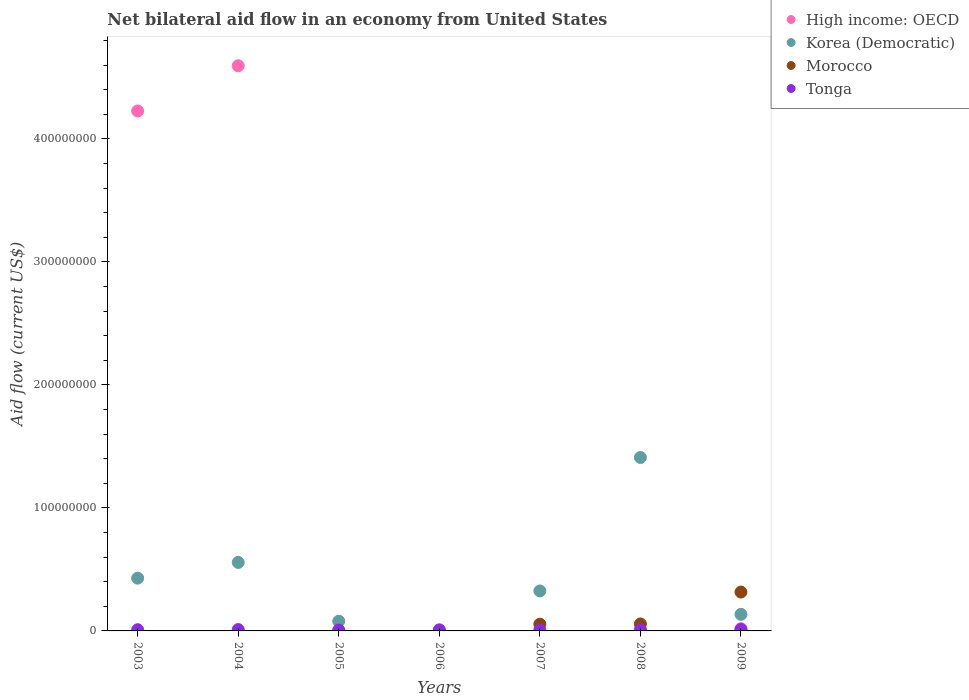Across all years, what is the maximum net bilateral aid flow in Morocco?
Ensure brevity in your answer.  3.16e+07. Across all years, what is the minimum net bilateral aid flow in Tonga?
Keep it short and to the point. 7.40e+05. In which year was the net bilateral aid flow in High income: OECD maximum?
Make the answer very short. 2004. What is the total net bilateral aid flow in Korea (Democratic) in the graph?
Offer a terse response. 2.94e+08. What is the difference between the net bilateral aid flow in Tonga in 2003 and that in 2005?
Keep it short and to the point. 2.40e+05. What is the average net bilateral aid flow in Morocco per year?
Your answer should be very brief. 6.11e+06. In the year 2007, what is the difference between the net bilateral aid flow in Korea (Democratic) and net bilateral aid flow in Morocco?
Give a very brief answer. 2.70e+07. What is the ratio of the net bilateral aid flow in Morocco in 2008 to that in 2009?
Your answer should be compact. 0.18. Is the difference between the net bilateral aid flow in Korea (Democratic) in 2007 and 2008 greater than the difference between the net bilateral aid flow in Morocco in 2007 and 2008?
Offer a terse response. No. What is the difference between the highest and the second highest net bilateral aid flow in Morocco?
Provide a succinct answer. 2.59e+07. In how many years, is the net bilateral aid flow in Korea (Democratic) greater than the average net bilateral aid flow in Korea (Democratic) taken over all years?
Offer a very short reply. 3. Is it the case that in every year, the sum of the net bilateral aid flow in Tonga and net bilateral aid flow in High income: OECD  is greater than the sum of net bilateral aid flow in Korea (Democratic) and net bilateral aid flow in Morocco?
Offer a terse response. No. Is it the case that in every year, the sum of the net bilateral aid flow in High income: OECD and net bilateral aid flow in Tonga  is greater than the net bilateral aid flow in Morocco?
Provide a short and direct response. No. Is the net bilateral aid flow in Tonga strictly less than the net bilateral aid flow in Morocco over the years?
Offer a terse response. No. How many dotlines are there?
Offer a terse response. 4. How many years are there in the graph?
Provide a succinct answer. 7. How many legend labels are there?
Provide a short and direct response. 4. How are the legend labels stacked?
Provide a short and direct response. Vertical. What is the title of the graph?
Provide a succinct answer. Net bilateral aid flow in an economy from United States. Does "Bermuda" appear as one of the legend labels in the graph?
Ensure brevity in your answer.  No. What is the Aid flow (current US$) of High income: OECD in 2003?
Your response must be concise. 4.23e+08. What is the Aid flow (current US$) of Korea (Democratic) in 2003?
Ensure brevity in your answer.  4.29e+07. What is the Aid flow (current US$) in Morocco in 2003?
Provide a short and direct response. 0. What is the Aid flow (current US$) of Tonga in 2003?
Provide a short and direct response. 9.80e+05. What is the Aid flow (current US$) in High income: OECD in 2004?
Give a very brief answer. 4.60e+08. What is the Aid flow (current US$) in Korea (Democratic) in 2004?
Your answer should be very brief. 5.57e+07. What is the Aid flow (current US$) in Morocco in 2004?
Offer a terse response. 0. What is the Aid flow (current US$) in Tonga in 2004?
Provide a succinct answer. 1.09e+06. What is the Aid flow (current US$) of High income: OECD in 2005?
Your response must be concise. 0. What is the Aid flow (current US$) of Korea (Democratic) in 2005?
Make the answer very short. 7.91e+06. What is the Aid flow (current US$) of Tonga in 2005?
Ensure brevity in your answer.  7.40e+05. What is the Aid flow (current US$) in High income: OECD in 2006?
Give a very brief answer. 0. What is the Aid flow (current US$) in Morocco in 2006?
Give a very brief answer. 0. What is the Aid flow (current US$) in Korea (Democratic) in 2007?
Offer a terse response. 3.25e+07. What is the Aid flow (current US$) of Morocco in 2007?
Provide a succinct answer. 5.49e+06. What is the Aid flow (current US$) of Tonga in 2007?
Offer a terse response. 7.70e+05. What is the Aid flow (current US$) of High income: OECD in 2008?
Your answer should be compact. 9.50e+05. What is the Aid flow (current US$) of Korea (Democratic) in 2008?
Provide a short and direct response. 1.41e+08. What is the Aid flow (current US$) in Morocco in 2008?
Give a very brief answer. 5.68e+06. What is the Aid flow (current US$) of Tonga in 2008?
Offer a terse response. 8.30e+05. What is the Aid flow (current US$) of High income: OECD in 2009?
Give a very brief answer. 1.84e+06. What is the Aid flow (current US$) of Korea (Democratic) in 2009?
Offer a very short reply. 1.35e+07. What is the Aid flow (current US$) of Morocco in 2009?
Offer a terse response. 3.16e+07. What is the Aid flow (current US$) of Tonga in 2009?
Keep it short and to the point. 1.21e+06. Across all years, what is the maximum Aid flow (current US$) in High income: OECD?
Your response must be concise. 4.60e+08. Across all years, what is the maximum Aid flow (current US$) in Korea (Democratic)?
Provide a short and direct response. 1.41e+08. Across all years, what is the maximum Aid flow (current US$) of Morocco?
Keep it short and to the point. 3.16e+07. Across all years, what is the maximum Aid flow (current US$) of Tonga?
Ensure brevity in your answer.  1.21e+06. Across all years, what is the minimum Aid flow (current US$) of High income: OECD?
Your response must be concise. 0. Across all years, what is the minimum Aid flow (current US$) of Morocco?
Provide a short and direct response. 0. Across all years, what is the minimum Aid flow (current US$) in Tonga?
Ensure brevity in your answer.  7.40e+05. What is the total Aid flow (current US$) in High income: OECD in the graph?
Offer a very short reply. 8.85e+08. What is the total Aid flow (current US$) in Korea (Democratic) in the graph?
Ensure brevity in your answer.  2.94e+08. What is the total Aid flow (current US$) of Morocco in the graph?
Offer a terse response. 4.28e+07. What is the total Aid flow (current US$) of Tonga in the graph?
Give a very brief answer. 6.52e+06. What is the difference between the Aid flow (current US$) in High income: OECD in 2003 and that in 2004?
Provide a succinct answer. -3.68e+07. What is the difference between the Aid flow (current US$) in Korea (Democratic) in 2003 and that in 2004?
Provide a short and direct response. -1.28e+07. What is the difference between the Aid flow (current US$) in Korea (Democratic) in 2003 and that in 2005?
Keep it short and to the point. 3.50e+07. What is the difference between the Aid flow (current US$) of Tonga in 2003 and that in 2005?
Offer a very short reply. 2.40e+05. What is the difference between the Aid flow (current US$) in Korea (Democratic) in 2003 and that in 2006?
Make the answer very short. 4.25e+07. What is the difference between the Aid flow (current US$) of Korea (Democratic) in 2003 and that in 2007?
Your answer should be very brief. 1.04e+07. What is the difference between the Aid flow (current US$) of High income: OECD in 2003 and that in 2008?
Give a very brief answer. 4.22e+08. What is the difference between the Aid flow (current US$) of Korea (Democratic) in 2003 and that in 2008?
Provide a short and direct response. -9.81e+07. What is the difference between the Aid flow (current US$) in High income: OECD in 2003 and that in 2009?
Make the answer very short. 4.21e+08. What is the difference between the Aid flow (current US$) of Korea (Democratic) in 2003 and that in 2009?
Your answer should be very brief. 2.94e+07. What is the difference between the Aid flow (current US$) of Korea (Democratic) in 2004 and that in 2005?
Provide a succinct answer. 4.78e+07. What is the difference between the Aid flow (current US$) in Tonga in 2004 and that in 2005?
Keep it short and to the point. 3.50e+05. What is the difference between the Aid flow (current US$) of Korea (Democratic) in 2004 and that in 2006?
Offer a very short reply. 5.53e+07. What is the difference between the Aid flow (current US$) in Korea (Democratic) in 2004 and that in 2007?
Your response must be concise. 2.32e+07. What is the difference between the Aid flow (current US$) in High income: OECD in 2004 and that in 2008?
Provide a succinct answer. 4.59e+08. What is the difference between the Aid flow (current US$) of Korea (Democratic) in 2004 and that in 2008?
Provide a short and direct response. -8.53e+07. What is the difference between the Aid flow (current US$) of Tonga in 2004 and that in 2008?
Provide a succinct answer. 2.60e+05. What is the difference between the Aid flow (current US$) of High income: OECD in 2004 and that in 2009?
Provide a short and direct response. 4.58e+08. What is the difference between the Aid flow (current US$) in Korea (Democratic) in 2004 and that in 2009?
Give a very brief answer. 4.22e+07. What is the difference between the Aid flow (current US$) in Korea (Democratic) in 2005 and that in 2006?
Provide a short and direct response. 7.51e+06. What is the difference between the Aid flow (current US$) in Korea (Democratic) in 2005 and that in 2007?
Make the answer very short. -2.46e+07. What is the difference between the Aid flow (current US$) of Tonga in 2005 and that in 2007?
Offer a terse response. -3.00e+04. What is the difference between the Aid flow (current US$) of Korea (Democratic) in 2005 and that in 2008?
Your answer should be very brief. -1.33e+08. What is the difference between the Aid flow (current US$) in Tonga in 2005 and that in 2008?
Offer a very short reply. -9.00e+04. What is the difference between the Aid flow (current US$) in Korea (Democratic) in 2005 and that in 2009?
Your answer should be very brief. -5.58e+06. What is the difference between the Aid flow (current US$) in Tonga in 2005 and that in 2009?
Offer a terse response. -4.70e+05. What is the difference between the Aid flow (current US$) in Korea (Democratic) in 2006 and that in 2007?
Give a very brief answer. -3.21e+07. What is the difference between the Aid flow (current US$) of Korea (Democratic) in 2006 and that in 2008?
Provide a short and direct response. -1.41e+08. What is the difference between the Aid flow (current US$) of Tonga in 2006 and that in 2008?
Your response must be concise. 7.00e+04. What is the difference between the Aid flow (current US$) in Korea (Democratic) in 2006 and that in 2009?
Provide a short and direct response. -1.31e+07. What is the difference between the Aid flow (current US$) in Tonga in 2006 and that in 2009?
Give a very brief answer. -3.10e+05. What is the difference between the Aid flow (current US$) of Korea (Democratic) in 2007 and that in 2008?
Offer a very short reply. -1.09e+08. What is the difference between the Aid flow (current US$) of Tonga in 2007 and that in 2008?
Offer a very short reply. -6.00e+04. What is the difference between the Aid flow (current US$) in Korea (Democratic) in 2007 and that in 2009?
Offer a terse response. 1.90e+07. What is the difference between the Aid flow (current US$) in Morocco in 2007 and that in 2009?
Provide a short and direct response. -2.61e+07. What is the difference between the Aid flow (current US$) of Tonga in 2007 and that in 2009?
Your answer should be very brief. -4.40e+05. What is the difference between the Aid flow (current US$) of High income: OECD in 2008 and that in 2009?
Give a very brief answer. -8.90e+05. What is the difference between the Aid flow (current US$) of Korea (Democratic) in 2008 and that in 2009?
Give a very brief answer. 1.28e+08. What is the difference between the Aid flow (current US$) in Morocco in 2008 and that in 2009?
Your answer should be very brief. -2.59e+07. What is the difference between the Aid flow (current US$) of Tonga in 2008 and that in 2009?
Offer a terse response. -3.80e+05. What is the difference between the Aid flow (current US$) in High income: OECD in 2003 and the Aid flow (current US$) in Korea (Democratic) in 2004?
Provide a succinct answer. 3.67e+08. What is the difference between the Aid flow (current US$) of High income: OECD in 2003 and the Aid flow (current US$) of Tonga in 2004?
Your response must be concise. 4.22e+08. What is the difference between the Aid flow (current US$) in Korea (Democratic) in 2003 and the Aid flow (current US$) in Tonga in 2004?
Keep it short and to the point. 4.18e+07. What is the difference between the Aid flow (current US$) of High income: OECD in 2003 and the Aid flow (current US$) of Korea (Democratic) in 2005?
Your response must be concise. 4.15e+08. What is the difference between the Aid flow (current US$) in High income: OECD in 2003 and the Aid flow (current US$) in Tonga in 2005?
Keep it short and to the point. 4.22e+08. What is the difference between the Aid flow (current US$) in Korea (Democratic) in 2003 and the Aid flow (current US$) in Tonga in 2005?
Offer a very short reply. 4.22e+07. What is the difference between the Aid flow (current US$) of High income: OECD in 2003 and the Aid flow (current US$) of Korea (Democratic) in 2006?
Your response must be concise. 4.22e+08. What is the difference between the Aid flow (current US$) of High income: OECD in 2003 and the Aid flow (current US$) of Tonga in 2006?
Offer a very short reply. 4.22e+08. What is the difference between the Aid flow (current US$) of Korea (Democratic) in 2003 and the Aid flow (current US$) of Tonga in 2006?
Provide a short and direct response. 4.20e+07. What is the difference between the Aid flow (current US$) of High income: OECD in 2003 and the Aid flow (current US$) of Korea (Democratic) in 2007?
Your response must be concise. 3.90e+08. What is the difference between the Aid flow (current US$) of High income: OECD in 2003 and the Aid flow (current US$) of Morocco in 2007?
Your answer should be very brief. 4.17e+08. What is the difference between the Aid flow (current US$) of High income: OECD in 2003 and the Aid flow (current US$) of Tonga in 2007?
Make the answer very short. 4.22e+08. What is the difference between the Aid flow (current US$) of Korea (Democratic) in 2003 and the Aid flow (current US$) of Morocco in 2007?
Offer a terse response. 3.74e+07. What is the difference between the Aid flow (current US$) of Korea (Democratic) in 2003 and the Aid flow (current US$) of Tonga in 2007?
Your answer should be compact. 4.21e+07. What is the difference between the Aid flow (current US$) of High income: OECD in 2003 and the Aid flow (current US$) of Korea (Democratic) in 2008?
Keep it short and to the point. 2.82e+08. What is the difference between the Aid flow (current US$) in High income: OECD in 2003 and the Aid flow (current US$) in Morocco in 2008?
Give a very brief answer. 4.17e+08. What is the difference between the Aid flow (current US$) in High income: OECD in 2003 and the Aid flow (current US$) in Tonga in 2008?
Your response must be concise. 4.22e+08. What is the difference between the Aid flow (current US$) of Korea (Democratic) in 2003 and the Aid flow (current US$) of Morocco in 2008?
Your answer should be compact. 3.72e+07. What is the difference between the Aid flow (current US$) in Korea (Democratic) in 2003 and the Aid flow (current US$) in Tonga in 2008?
Your response must be concise. 4.21e+07. What is the difference between the Aid flow (current US$) in High income: OECD in 2003 and the Aid flow (current US$) in Korea (Democratic) in 2009?
Offer a very short reply. 4.09e+08. What is the difference between the Aid flow (current US$) in High income: OECD in 2003 and the Aid flow (current US$) in Morocco in 2009?
Provide a succinct answer. 3.91e+08. What is the difference between the Aid flow (current US$) in High income: OECD in 2003 and the Aid flow (current US$) in Tonga in 2009?
Your answer should be compact. 4.22e+08. What is the difference between the Aid flow (current US$) in Korea (Democratic) in 2003 and the Aid flow (current US$) in Morocco in 2009?
Offer a terse response. 1.13e+07. What is the difference between the Aid flow (current US$) of Korea (Democratic) in 2003 and the Aid flow (current US$) of Tonga in 2009?
Keep it short and to the point. 4.17e+07. What is the difference between the Aid flow (current US$) in High income: OECD in 2004 and the Aid flow (current US$) in Korea (Democratic) in 2005?
Give a very brief answer. 4.52e+08. What is the difference between the Aid flow (current US$) in High income: OECD in 2004 and the Aid flow (current US$) in Tonga in 2005?
Your answer should be very brief. 4.59e+08. What is the difference between the Aid flow (current US$) of Korea (Democratic) in 2004 and the Aid flow (current US$) of Tonga in 2005?
Offer a terse response. 5.50e+07. What is the difference between the Aid flow (current US$) of High income: OECD in 2004 and the Aid flow (current US$) of Korea (Democratic) in 2006?
Provide a short and direct response. 4.59e+08. What is the difference between the Aid flow (current US$) in High income: OECD in 2004 and the Aid flow (current US$) in Tonga in 2006?
Provide a short and direct response. 4.59e+08. What is the difference between the Aid flow (current US$) of Korea (Democratic) in 2004 and the Aid flow (current US$) of Tonga in 2006?
Give a very brief answer. 5.48e+07. What is the difference between the Aid flow (current US$) of High income: OECD in 2004 and the Aid flow (current US$) of Korea (Democratic) in 2007?
Your response must be concise. 4.27e+08. What is the difference between the Aid flow (current US$) of High income: OECD in 2004 and the Aid flow (current US$) of Morocco in 2007?
Your answer should be very brief. 4.54e+08. What is the difference between the Aid flow (current US$) of High income: OECD in 2004 and the Aid flow (current US$) of Tonga in 2007?
Ensure brevity in your answer.  4.59e+08. What is the difference between the Aid flow (current US$) in Korea (Democratic) in 2004 and the Aid flow (current US$) in Morocco in 2007?
Give a very brief answer. 5.02e+07. What is the difference between the Aid flow (current US$) in Korea (Democratic) in 2004 and the Aid flow (current US$) in Tonga in 2007?
Ensure brevity in your answer.  5.49e+07. What is the difference between the Aid flow (current US$) of High income: OECD in 2004 and the Aid flow (current US$) of Korea (Democratic) in 2008?
Ensure brevity in your answer.  3.18e+08. What is the difference between the Aid flow (current US$) in High income: OECD in 2004 and the Aid flow (current US$) in Morocco in 2008?
Keep it short and to the point. 4.54e+08. What is the difference between the Aid flow (current US$) in High income: OECD in 2004 and the Aid flow (current US$) in Tonga in 2008?
Provide a succinct answer. 4.59e+08. What is the difference between the Aid flow (current US$) in Korea (Democratic) in 2004 and the Aid flow (current US$) in Morocco in 2008?
Your response must be concise. 5.00e+07. What is the difference between the Aid flow (current US$) of Korea (Democratic) in 2004 and the Aid flow (current US$) of Tonga in 2008?
Offer a terse response. 5.49e+07. What is the difference between the Aid flow (current US$) in High income: OECD in 2004 and the Aid flow (current US$) in Korea (Democratic) in 2009?
Ensure brevity in your answer.  4.46e+08. What is the difference between the Aid flow (current US$) of High income: OECD in 2004 and the Aid flow (current US$) of Morocco in 2009?
Make the answer very short. 4.28e+08. What is the difference between the Aid flow (current US$) of High income: OECD in 2004 and the Aid flow (current US$) of Tonga in 2009?
Make the answer very short. 4.58e+08. What is the difference between the Aid flow (current US$) of Korea (Democratic) in 2004 and the Aid flow (current US$) of Morocco in 2009?
Give a very brief answer. 2.41e+07. What is the difference between the Aid flow (current US$) in Korea (Democratic) in 2004 and the Aid flow (current US$) in Tonga in 2009?
Offer a terse response. 5.45e+07. What is the difference between the Aid flow (current US$) of Korea (Democratic) in 2005 and the Aid flow (current US$) of Tonga in 2006?
Give a very brief answer. 7.01e+06. What is the difference between the Aid flow (current US$) of Korea (Democratic) in 2005 and the Aid flow (current US$) of Morocco in 2007?
Keep it short and to the point. 2.42e+06. What is the difference between the Aid flow (current US$) of Korea (Democratic) in 2005 and the Aid flow (current US$) of Tonga in 2007?
Your answer should be very brief. 7.14e+06. What is the difference between the Aid flow (current US$) in Korea (Democratic) in 2005 and the Aid flow (current US$) in Morocco in 2008?
Ensure brevity in your answer.  2.23e+06. What is the difference between the Aid flow (current US$) in Korea (Democratic) in 2005 and the Aid flow (current US$) in Tonga in 2008?
Your response must be concise. 7.08e+06. What is the difference between the Aid flow (current US$) in Korea (Democratic) in 2005 and the Aid flow (current US$) in Morocco in 2009?
Keep it short and to the point. -2.37e+07. What is the difference between the Aid flow (current US$) of Korea (Democratic) in 2005 and the Aid flow (current US$) of Tonga in 2009?
Your answer should be very brief. 6.70e+06. What is the difference between the Aid flow (current US$) in Korea (Democratic) in 2006 and the Aid flow (current US$) in Morocco in 2007?
Offer a very short reply. -5.09e+06. What is the difference between the Aid flow (current US$) of Korea (Democratic) in 2006 and the Aid flow (current US$) of Tonga in 2007?
Provide a succinct answer. -3.70e+05. What is the difference between the Aid flow (current US$) of Korea (Democratic) in 2006 and the Aid flow (current US$) of Morocco in 2008?
Provide a succinct answer. -5.28e+06. What is the difference between the Aid flow (current US$) of Korea (Democratic) in 2006 and the Aid flow (current US$) of Tonga in 2008?
Provide a succinct answer. -4.30e+05. What is the difference between the Aid flow (current US$) in Korea (Democratic) in 2006 and the Aid flow (current US$) in Morocco in 2009?
Make the answer very short. -3.12e+07. What is the difference between the Aid flow (current US$) in Korea (Democratic) in 2006 and the Aid flow (current US$) in Tonga in 2009?
Your response must be concise. -8.10e+05. What is the difference between the Aid flow (current US$) of Korea (Democratic) in 2007 and the Aid flow (current US$) of Morocco in 2008?
Offer a very short reply. 2.68e+07. What is the difference between the Aid flow (current US$) in Korea (Democratic) in 2007 and the Aid flow (current US$) in Tonga in 2008?
Provide a short and direct response. 3.17e+07. What is the difference between the Aid flow (current US$) of Morocco in 2007 and the Aid flow (current US$) of Tonga in 2008?
Offer a terse response. 4.66e+06. What is the difference between the Aid flow (current US$) of Korea (Democratic) in 2007 and the Aid flow (current US$) of Morocco in 2009?
Make the answer very short. 9.10e+05. What is the difference between the Aid flow (current US$) in Korea (Democratic) in 2007 and the Aid flow (current US$) in Tonga in 2009?
Your answer should be very brief. 3.13e+07. What is the difference between the Aid flow (current US$) of Morocco in 2007 and the Aid flow (current US$) of Tonga in 2009?
Make the answer very short. 4.28e+06. What is the difference between the Aid flow (current US$) of High income: OECD in 2008 and the Aid flow (current US$) of Korea (Democratic) in 2009?
Your answer should be compact. -1.25e+07. What is the difference between the Aid flow (current US$) of High income: OECD in 2008 and the Aid flow (current US$) of Morocco in 2009?
Provide a short and direct response. -3.06e+07. What is the difference between the Aid flow (current US$) in High income: OECD in 2008 and the Aid flow (current US$) in Tonga in 2009?
Your response must be concise. -2.60e+05. What is the difference between the Aid flow (current US$) of Korea (Democratic) in 2008 and the Aid flow (current US$) of Morocco in 2009?
Keep it short and to the point. 1.09e+08. What is the difference between the Aid flow (current US$) in Korea (Democratic) in 2008 and the Aid flow (current US$) in Tonga in 2009?
Make the answer very short. 1.40e+08. What is the difference between the Aid flow (current US$) in Morocco in 2008 and the Aid flow (current US$) in Tonga in 2009?
Keep it short and to the point. 4.47e+06. What is the average Aid flow (current US$) of High income: OECD per year?
Make the answer very short. 1.26e+08. What is the average Aid flow (current US$) of Korea (Democratic) per year?
Offer a terse response. 4.20e+07. What is the average Aid flow (current US$) of Morocco per year?
Give a very brief answer. 6.11e+06. What is the average Aid flow (current US$) in Tonga per year?
Offer a very short reply. 9.31e+05. In the year 2003, what is the difference between the Aid flow (current US$) of High income: OECD and Aid flow (current US$) of Korea (Democratic)?
Provide a short and direct response. 3.80e+08. In the year 2003, what is the difference between the Aid flow (current US$) of High income: OECD and Aid flow (current US$) of Tonga?
Provide a short and direct response. 4.22e+08. In the year 2003, what is the difference between the Aid flow (current US$) of Korea (Democratic) and Aid flow (current US$) of Tonga?
Give a very brief answer. 4.19e+07. In the year 2004, what is the difference between the Aid flow (current US$) of High income: OECD and Aid flow (current US$) of Korea (Democratic)?
Provide a succinct answer. 4.04e+08. In the year 2004, what is the difference between the Aid flow (current US$) of High income: OECD and Aid flow (current US$) of Tonga?
Keep it short and to the point. 4.58e+08. In the year 2004, what is the difference between the Aid flow (current US$) of Korea (Democratic) and Aid flow (current US$) of Tonga?
Your answer should be compact. 5.46e+07. In the year 2005, what is the difference between the Aid flow (current US$) of Korea (Democratic) and Aid flow (current US$) of Tonga?
Keep it short and to the point. 7.17e+06. In the year 2006, what is the difference between the Aid flow (current US$) in Korea (Democratic) and Aid flow (current US$) in Tonga?
Keep it short and to the point. -5.00e+05. In the year 2007, what is the difference between the Aid flow (current US$) of Korea (Democratic) and Aid flow (current US$) of Morocco?
Make the answer very short. 2.70e+07. In the year 2007, what is the difference between the Aid flow (current US$) in Korea (Democratic) and Aid flow (current US$) in Tonga?
Your response must be concise. 3.17e+07. In the year 2007, what is the difference between the Aid flow (current US$) in Morocco and Aid flow (current US$) in Tonga?
Make the answer very short. 4.72e+06. In the year 2008, what is the difference between the Aid flow (current US$) of High income: OECD and Aid flow (current US$) of Korea (Democratic)?
Offer a very short reply. -1.40e+08. In the year 2008, what is the difference between the Aid flow (current US$) in High income: OECD and Aid flow (current US$) in Morocco?
Your answer should be compact. -4.73e+06. In the year 2008, what is the difference between the Aid flow (current US$) of High income: OECD and Aid flow (current US$) of Tonga?
Your answer should be compact. 1.20e+05. In the year 2008, what is the difference between the Aid flow (current US$) in Korea (Democratic) and Aid flow (current US$) in Morocco?
Your response must be concise. 1.35e+08. In the year 2008, what is the difference between the Aid flow (current US$) in Korea (Democratic) and Aid flow (current US$) in Tonga?
Your answer should be very brief. 1.40e+08. In the year 2008, what is the difference between the Aid flow (current US$) of Morocco and Aid flow (current US$) of Tonga?
Offer a terse response. 4.85e+06. In the year 2009, what is the difference between the Aid flow (current US$) in High income: OECD and Aid flow (current US$) in Korea (Democratic)?
Give a very brief answer. -1.16e+07. In the year 2009, what is the difference between the Aid flow (current US$) of High income: OECD and Aid flow (current US$) of Morocco?
Make the answer very short. -2.98e+07. In the year 2009, what is the difference between the Aid flow (current US$) of High income: OECD and Aid flow (current US$) of Tonga?
Offer a terse response. 6.30e+05. In the year 2009, what is the difference between the Aid flow (current US$) in Korea (Democratic) and Aid flow (current US$) in Morocco?
Provide a succinct answer. -1.81e+07. In the year 2009, what is the difference between the Aid flow (current US$) of Korea (Democratic) and Aid flow (current US$) of Tonga?
Provide a succinct answer. 1.23e+07. In the year 2009, what is the difference between the Aid flow (current US$) of Morocco and Aid flow (current US$) of Tonga?
Your response must be concise. 3.04e+07. What is the ratio of the Aid flow (current US$) of High income: OECD in 2003 to that in 2004?
Your answer should be compact. 0.92. What is the ratio of the Aid flow (current US$) in Korea (Democratic) in 2003 to that in 2004?
Provide a short and direct response. 0.77. What is the ratio of the Aid flow (current US$) in Tonga in 2003 to that in 2004?
Your answer should be compact. 0.9. What is the ratio of the Aid flow (current US$) in Korea (Democratic) in 2003 to that in 2005?
Offer a terse response. 5.42. What is the ratio of the Aid flow (current US$) of Tonga in 2003 to that in 2005?
Your answer should be very brief. 1.32. What is the ratio of the Aid flow (current US$) of Korea (Democratic) in 2003 to that in 2006?
Your answer should be compact. 107.25. What is the ratio of the Aid flow (current US$) in Tonga in 2003 to that in 2006?
Your answer should be very brief. 1.09. What is the ratio of the Aid flow (current US$) in Korea (Democratic) in 2003 to that in 2007?
Your response must be concise. 1.32. What is the ratio of the Aid flow (current US$) in Tonga in 2003 to that in 2007?
Offer a very short reply. 1.27. What is the ratio of the Aid flow (current US$) of High income: OECD in 2003 to that in 2008?
Your response must be concise. 445.02. What is the ratio of the Aid flow (current US$) of Korea (Democratic) in 2003 to that in 2008?
Keep it short and to the point. 0.3. What is the ratio of the Aid flow (current US$) of Tonga in 2003 to that in 2008?
Keep it short and to the point. 1.18. What is the ratio of the Aid flow (current US$) of High income: OECD in 2003 to that in 2009?
Give a very brief answer. 229.77. What is the ratio of the Aid flow (current US$) in Korea (Democratic) in 2003 to that in 2009?
Offer a very short reply. 3.18. What is the ratio of the Aid flow (current US$) of Tonga in 2003 to that in 2009?
Offer a terse response. 0.81. What is the ratio of the Aid flow (current US$) in Korea (Democratic) in 2004 to that in 2005?
Keep it short and to the point. 7.04. What is the ratio of the Aid flow (current US$) in Tonga in 2004 to that in 2005?
Your answer should be very brief. 1.47. What is the ratio of the Aid flow (current US$) in Korea (Democratic) in 2004 to that in 2006?
Ensure brevity in your answer.  139.28. What is the ratio of the Aid flow (current US$) of Tonga in 2004 to that in 2006?
Your answer should be compact. 1.21. What is the ratio of the Aid flow (current US$) of Korea (Democratic) in 2004 to that in 2007?
Make the answer very short. 1.71. What is the ratio of the Aid flow (current US$) in Tonga in 2004 to that in 2007?
Provide a succinct answer. 1.42. What is the ratio of the Aid flow (current US$) of High income: OECD in 2004 to that in 2008?
Ensure brevity in your answer.  483.73. What is the ratio of the Aid flow (current US$) in Korea (Democratic) in 2004 to that in 2008?
Make the answer very short. 0.4. What is the ratio of the Aid flow (current US$) in Tonga in 2004 to that in 2008?
Provide a succinct answer. 1.31. What is the ratio of the Aid flow (current US$) of High income: OECD in 2004 to that in 2009?
Provide a short and direct response. 249.75. What is the ratio of the Aid flow (current US$) in Korea (Democratic) in 2004 to that in 2009?
Provide a short and direct response. 4.13. What is the ratio of the Aid flow (current US$) of Tonga in 2004 to that in 2009?
Offer a terse response. 0.9. What is the ratio of the Aid flow (current US$) of Korea (Democratic) in 2005 to that in 2006?
Give a very brief answer. 19.77. What is the ratio of the Aid flow (current US$) of Tonga in 2005 to that in 2006?
Your answer should be compact. 0.82. What is the ratio of the Aid flow (current US$) in Korea (Democratic) in 2005 to that in 2007?
Make the answer very short. 0.24. What is the ratio of the Aid flow (current US$) in Tonga in 2005 to that in 2007?
Provide a short and direct response. 0.96. What is the ratio of the Aid flow (current US$) of Korea (Democratic) in 2005 to that in 2008?
Make the answer very short. 0.06. What is the ratio of the Aid flow (current US$) in Tonga in 2005 to that in 2008?
Make the answer very short. 0.89. What is the ratio of the Aid flow (current US$) of Korea (Democratic) in 2005 to that in 2009?
Your response must be concise. 0.59. What is the ratio of the Aid flow (current US$) of Tonga in 2005 to that in 2009?
Your response must be concise. 0.61. What is the ratio of the Aid flow (current US$) of Korea (Democratic) in 2006 to that in 2007?
Give a very brief answer. 0.01. What is the ratio of the Aid flow (current US$) of Tonga in 2006 to that in 2007?
Your answer should be very brief. 1.17. What is the ratio of the Aid flow (current US$) of Korea (Democratic) in 2006 to that in 2008?
Your response must be concise. 0. What is the ratio of the Aid flow (current US$) in Tonga in 2006 to that in 2008?
Offer a very short reply. 1.08. What is the ratio of the Aid flow (current US$) of Korea (Democratic) in 2006 to that in 2009?
Ensure brevity in your answer.  0.03. What is the ratio of the Aid flow (current US$) of Tonga in 2006 to that in 2009?
Your answer should be compact. 0.74. What is the ratio of the Aid flow (current US$) of Korea (Democratic) in 2007 to that in 2008?
Provide a short and direct response. 0.23. What is the ratio of the Aid flow (current US$) in Morocco in 2007 to that in 2008?
Give a very brief answer. 0.97. What is the ratio of the Aid flow (current US$) in Tonga in 2007 to that in 2008?
Your response must be concise. 0.93. What is the ratio of the Aid flow (current US$) of Korea (Democratic) in 2007 to that in 2009?
Offer a very short reply. 2.41. What is the ratio of the Aid flow (current US$) of Morocco in 2007 to that in 2009?
Your response must be concise. 0.17. What is the ratio of the Aid flow (current US$) in Tonga in 2007 to that in 2009?
Provide a succinct answer. 0.64. What is the ratio of the Aid flow (current US$) of High income: OECD in 2008 to that in 2009?
Keep it short and to the point. 0.52. What is the ratio of the Aid flow (current US$) in Korea (Democratic) in 2008 to that in 2009?
Offer a very short reply. 10.46. What is the ratio of the Aid flow (current US$) of Morocco in 2008 to that in 2009?
Your response must be concise. 0.18. What is the ratio of the Aid flow (current US$) of Tonga in 2008 to that in 2009?
Provide a succinct answer. 0.69. What is the difference between the highest and the second highest Aid flow (current US$) in High income: OECD?
Give a very brief answer. 3.68e+07. What is the difference between the highest and the second highest Aid flow (current US$) of Korea (Democratic)?
Give a very brief answer. 8.53e+07. What is the difference between the highest and the second highest Aid flow (current US$) in Morocco?
Give a very brief answer. 2.59e+07. What is the difference between the highest and the second highest Aid flow (current US$) of Tonga?
Provide a succinct answer. 1.20e+05. What is the difference between the highest and the lowest Aid flow (current US$) of High income: OECD?
Offer a very short reply. 4.60e+08. What is the difference between the highest and the lowest Aid flow (current US$) of Korea (Democratic)?
Provide a short and direct response. 1.41e+08. What is the difference between the highest and the lowest Aid flow (current US$) in Morocco?
Make the answer very short. 3.16e+07. What is the difference between the highest and the lowest Aid flow (current US$) of Tonga?
Provide a succinct answer. 4.70e+05. 